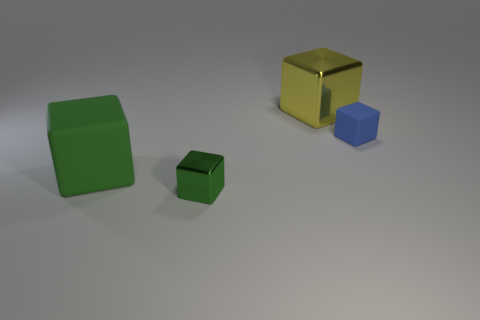Does the tiny matte thing have the same color as the tiny block in front of the big green matte object?
Give a very brief answer. No. How many tiny things are on the left side of the metallic thing that is to the left of the big yellow thing?
Make the answer very short. 0. There is a big block behind the rubber cube in front of the blue rubber object; what is its color?
Your response must be concise. Yellow. There is a cube that is both behind the tiny green metal block and to the left of the yellow cube; what material is it?
Provide a succinct answer. Rubber. Are there any brown matte things of the same shape as the yellow thing?
Your answer should be very brief. No. There is a big thing that is in front of the large yellow metallic block; is its shape the same as the small green object?
Keep it short and to the point. Yes. What number of things are both in front of the large yellow object and to the left of the blue thing?
Your response must be concise. 2. What number of tiny things have the same material as the large green thing?
Offer a terse response. 1. There is a large yellow object; does it have the same shape as the tiny thing that is right of the yellow block?
Your answer should be compact. Yes. There is a rubber block right of the metal block on the right side of the green metal block; are there any things in front of it?
Provide a short and direct response. Yes. 